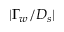Convert formula to latex. <formula><loc_0><loc_0><loc_500><loc_500>| \Gamma _ { w } / D _ { s } |</formula> 